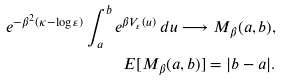Convert formula to latex. <formula><loc_0><loc_0><loc_500><loc_500>e ^ { - \beta ^ { 2 } ( \kappa - \log \varepsilon ) } \int _ { a } ^ { b } e ^ { \beta V _ { \varepsilon } ( u ) } \, d u \longrightarrow M _ { \beta } ( a , b ) , \\ { E } [ M _ { \beta } ( a , b ) ] = | b - a | .</formula> 